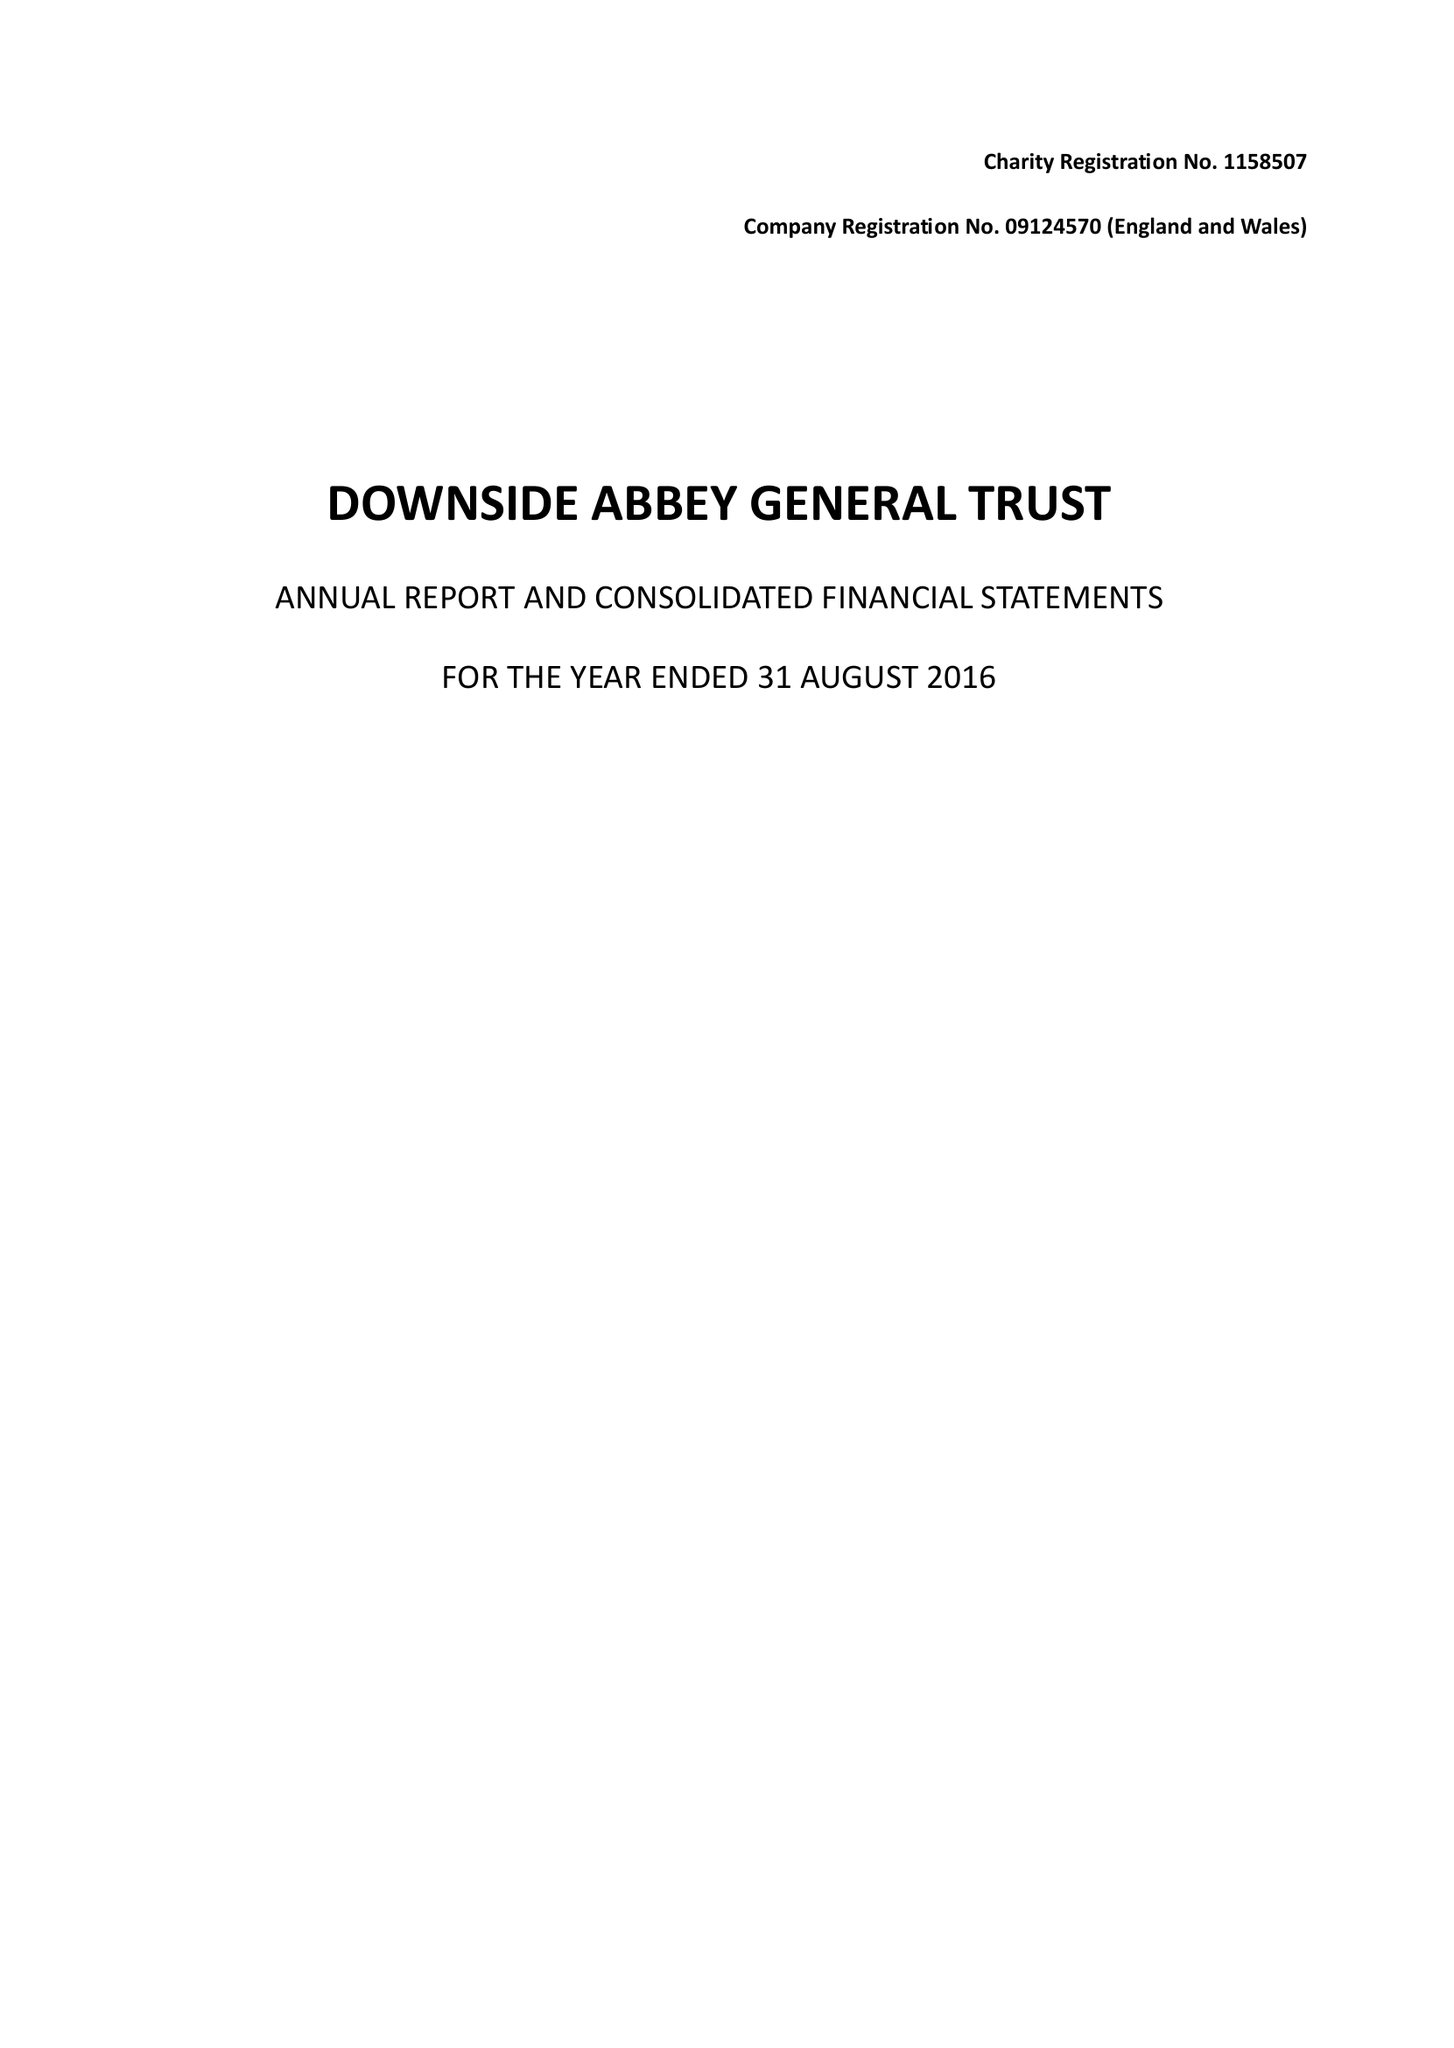What is the value for the spending_annually_in_british_pounds?
Answer the question using a single word or phrase. 9598467.00 